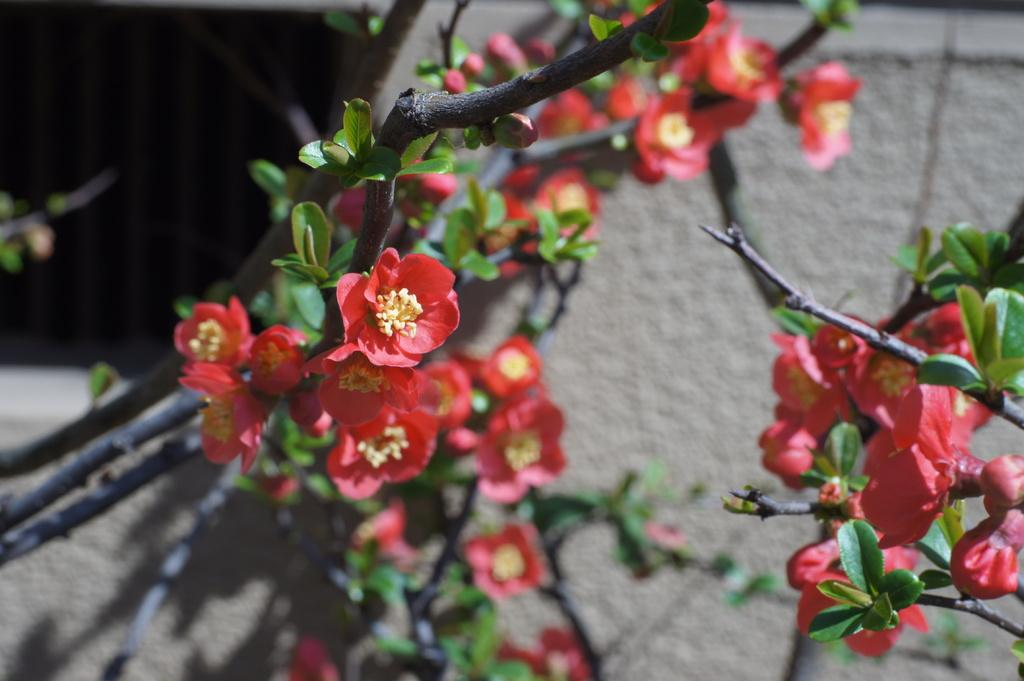What type of plant is depicted in the image? There are branches with flowers in the image. Are there any additional features on the branches? Yes, there are leaves on the branches. What can be seen in the background of the image? There is a wall visible in the background of the image. What type of structure does the son build in the image? There is no son or structure present in the image; it features branches with flowers and leaves. What kind of noise can be heard coming from the flowers in the image? There is no noise coming from the flowers in the image; they are not depicted as making any sound. 